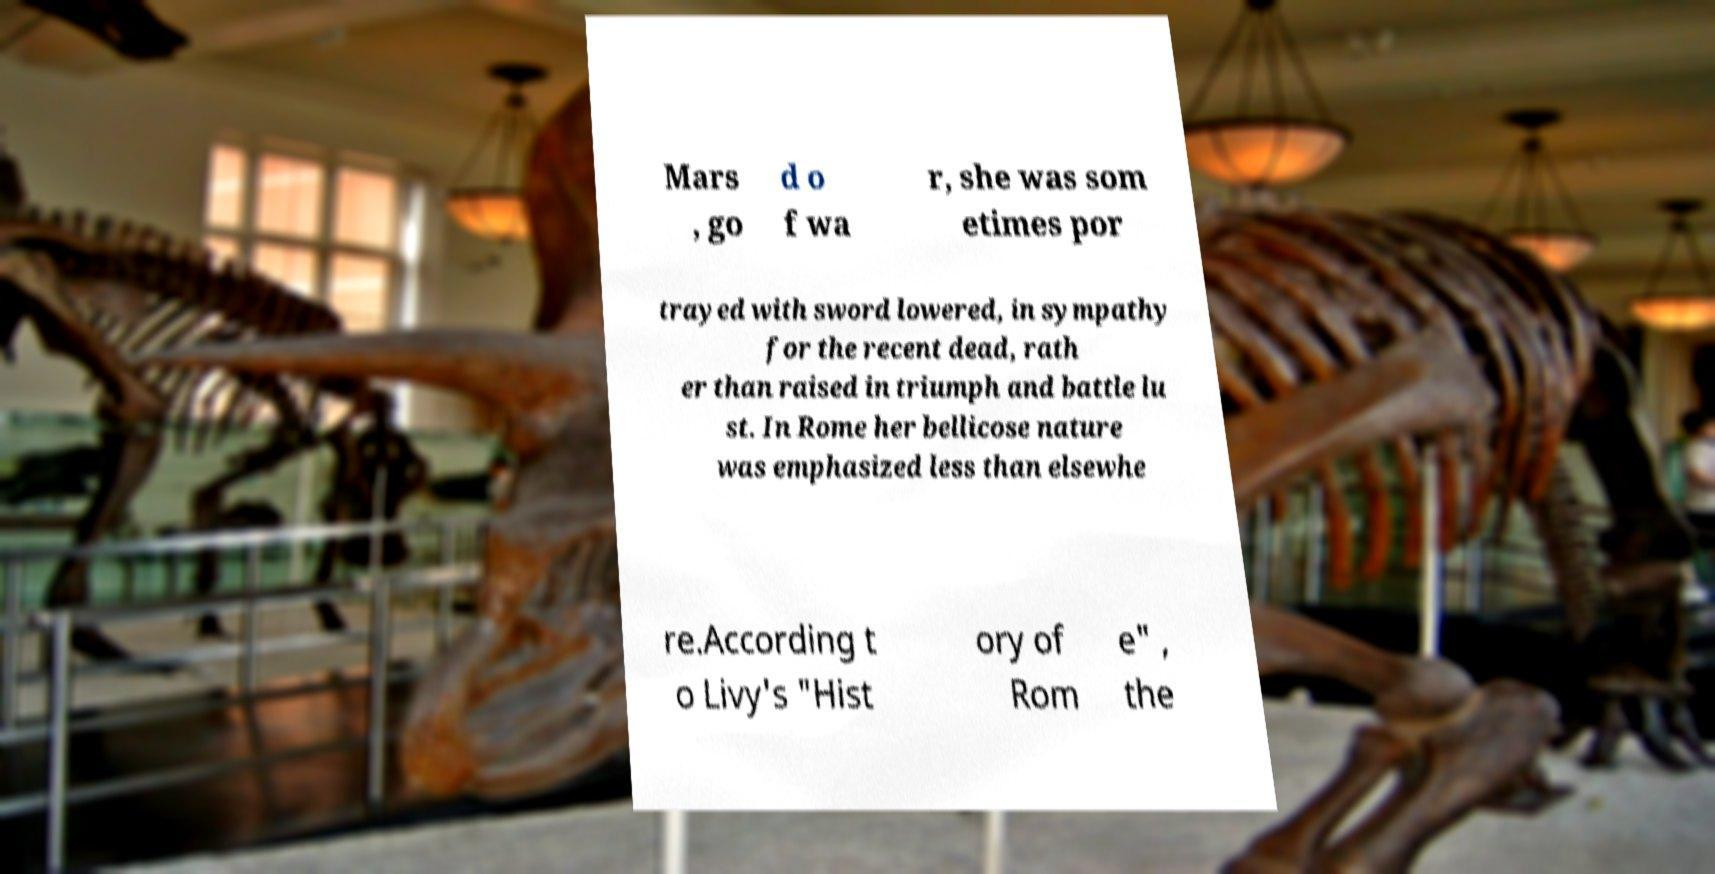For documentation purposes, I need the text within this image transcribed. Could you provide that? Mars , go d o f wa r, she was som etimes por trayed with sword lowered, in sympathy for the recent dead, rath er than raised in triumph and battle lu st. In Rome her bellicose nature was emphasized less than elsewhe re.According t o Livy's "Hist ory of Rom e" , the 